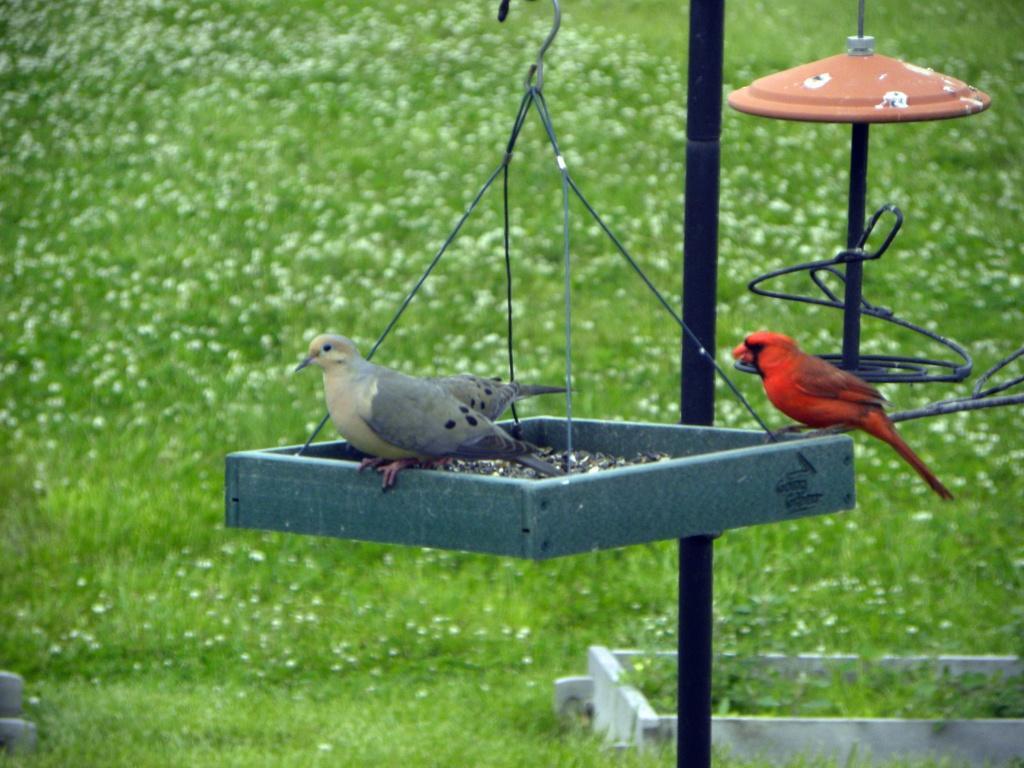In one or two sentences, can you explain what this image depicts? In the picture I can see two grey color birds and a red color bird is on the surface which is hanged to the hook. In the background, I can see few more objects hanged to the hooks and I can see the grass. 